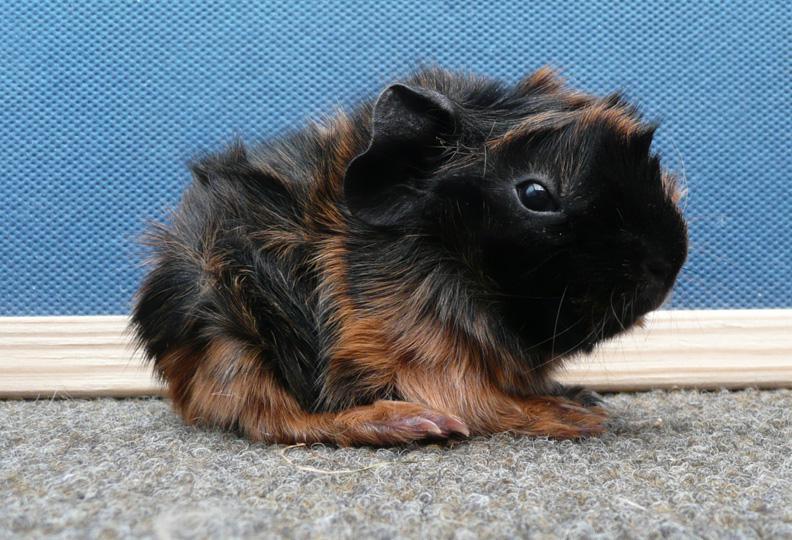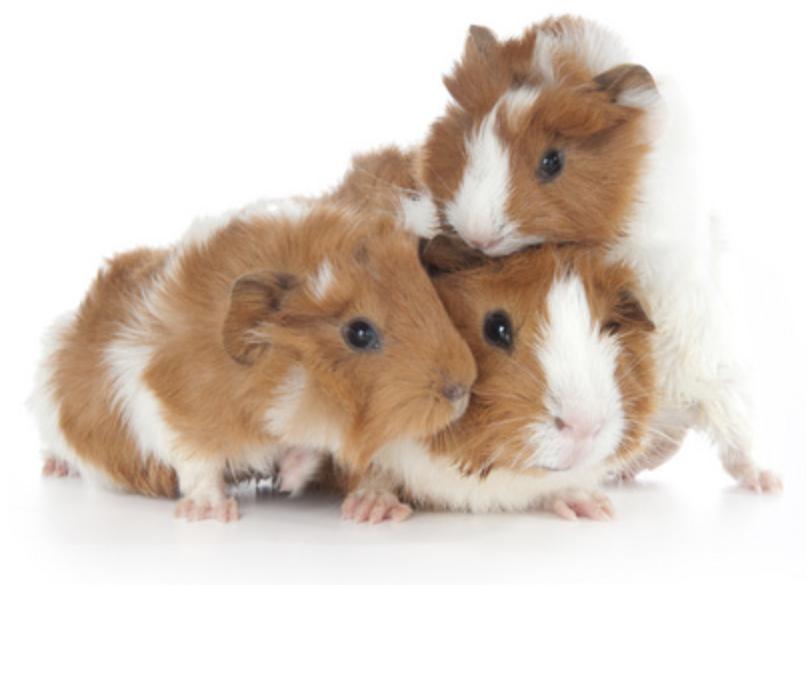The first image is the image on the left, the second image is the image on the right. Analyze the images presented: Is the assertion "There is at least two rodents in the right image." valid? Answer yes or no. Yes. The first image is the image on the left, the second image is the image on the right. Evaluate the accuracy of this statement regarding the images: "There are exactly two guinea pigs in total.". Is it true? Answer yes or no. No. 